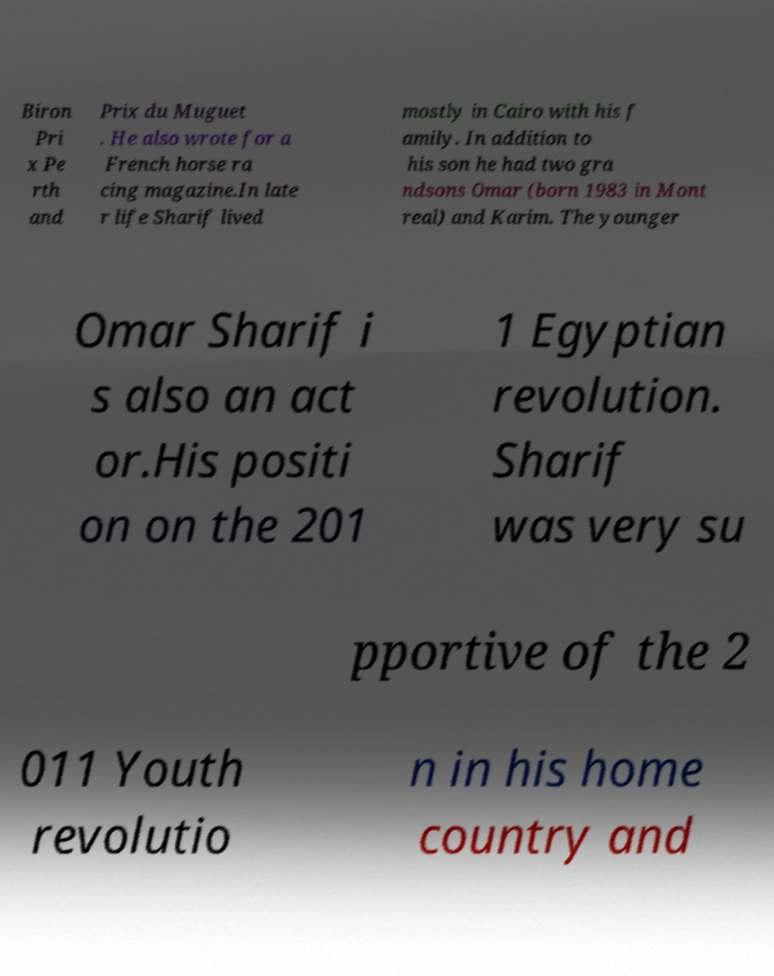Could you extract and type out the text from this image? Biron Pri x Pe rth and Prix du Muguet . He also wrote for a French horse ra cing magazine.In late r life Sharif lived mostly in Cairo with his f amily. In addition to his son he had two gra ndsons Omar (born 1983 in Mont real) and Karim. The younger Omar Sharif i s also an act or.His positi on on the 201 1 Egyptian revolution. Sharif was very su pportive of the 2 011 Youth revolutio n in his home country and 